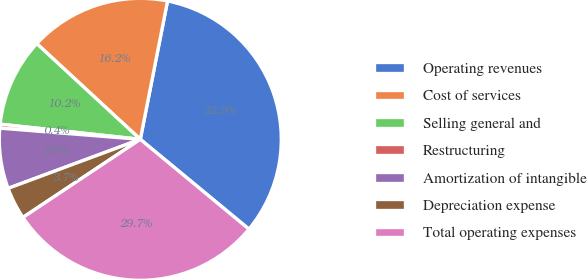Convert chart to OTSL. <chart><loc_0><loc_0><loc_500><loc_500><pie_chart><fcel>Operating revenues<fcel>Cost of services<fcel>Selling general and<fcel>Restructuring<fcel>Amortization of intangible<fcel>Depreciation expense<fcel>Total operating expenses<nl><fcel>32.9%<fcel>16.22%<fcel>10.16%<fcel>0.45%<fcel>6.92%<fcel>3.69%<fcel>29.66%<nl></chart> 